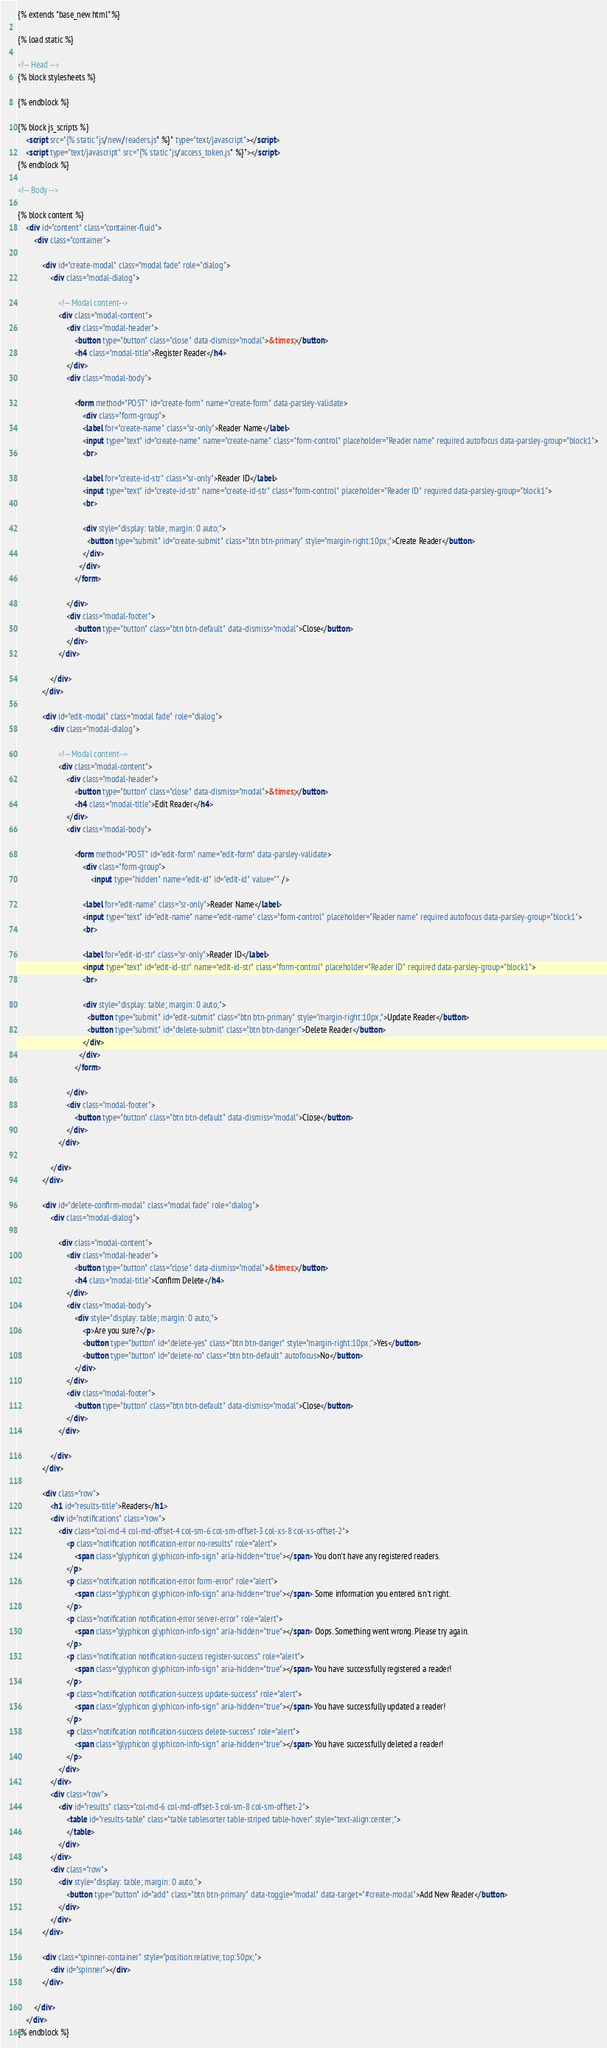Convert code to text. <code><loc_0><loc_0><loc_500><loc_500><_HTML_>{% extends "base_new.html" %}

{% load static %}

<!-- Head -->
{% block stylesheets %}
	
{% endblock %}

{% block js_scripts %}
	<script src="{% static "js/new/readers.js" %}" type="text/javascript"></script>
	<script type="text/javascript" src="{% static "js/access_token.js" %}"></script>
{% endblock %}

<!-- Body -->

{% block content %}
	<div id="content" class="container-fluid">
		<div class="container">

			<div id="create-modal" class="modal fade" role="dialog">
				<div class="modal-dialog">

					<!-- Modal content-->
					<div class="modal-content">
						<div class="modal-header">
							<button type="button" class="close" data-dismiss="modal">&times;</button>
							<h4 class="modal-title">Register Reader</h4>
						</div>
						<div class="modal-body">

							<form method="POST" id="create-form" name="create-form" data-parsley-validate>
								<div class="form-group">
							    <label for="create-name" class="sr-only">Reader Name</label>
							    <input type="text" id="create-name" name="create-name" class="form-control" placeholder="Reader name" required autofocus data-parsley-group="block1">
							    <br>

							    <label for="create-id-str" class="sr-only">Reader ID</label>
							    <input type="text" id="create-id-str" name="create-id-str" class="form-control" placeholder="Reader ID" required data-parsley-group="block1">
							    <br>

							    <div style="display: table; margin: 0 auto;">
							      <button type="submit" id="create-submit" class="btn btn-primary" style="margin-right:10px;">Create Reader</button>
							    </div>
							  </div>
							</form>

						</div>
						<div class="modal-footer">
							<button type="button" class="btn btn-default" data-dismiss="modal">Close</button>
						</div>
					</div>

				</div>
			</div>

			<div id="edit-modal" class="modal fade" role="dialog">
				<div class="modal-dialog">

					<!-- Modal content-->
					<div class="modal-content">
						<div class="modal-header">
							<button type="button" class="close" data-dismiss="modal">&times;</button>
							<h4 class="modal-title">Edit Reader</h4>
						</div>
						<div class="modal-body">

							<form method="POST" id="edit-form" name="edit-form" data-parsley-validate>
								<div class="form-group">
									<input type="hidden" name="edit-id" id="edit-id" value="" />

							    <label for="edit-name" class="sr-only">Reader Name</label>
							    <input type="text" id="edit-name" name="edit-name" class="form-control" placeholder="Reader name" required autofocus data-parsley-group="block1">
							    <br>

							    <label for="edit-id-str" class="sr-only">Reader ID</label>
							    <input type="text" id="edit-id-str" name="edit-id-str" class="form-control" placeholder="Reader ID" required data-parsley-group="block1">
							    <br>

							    <div style="display: table; margin: 0 auto;">
							      <button type="submit" id="edit-submit" class="btn btn-primary" style="margin-right:10px;">Update Reader</button>
							      <button type="submit" id="delete-submit" class="btn btn-danger">Delete Reader</button>
							    </div>
							  </div>
							</form>

						</div>
						<div class="modal-footer">
							<button type="button" class="btn btn-default" data-dismiss="modal">Close</button>
						</div>
					</div>

				</div>
			</div>

			<div id="delete-confirm-modal" class="modal fade" role="dialog">
				<div class="modal-dialog">

					<div class="modal-content">
						<div class="modal-header">
							<button type="button" class="close" data-dismiss="modal">&times;</button>
							<h4 class="modal-title">Confirm Delete</h4>
						</div>
						<div class="modal-body">
							<div style="display: table; margin: 0 auto;">
								<p>Are you sure?</p>
								<button type="button" id="delete-yes" class="btn btn-danger" style="margin-right:10px;">Yes</button>
								<button type="button" id="delete-no" class="btn btn-default" autofocus>No</button>
							</div>
						</div>
						<div class="modal-footer">
							<button type="button" class="btn btn-default" data-dismiss="modal">Close</button>
						</div>
					</div>

				</div>
			</div>

			<div class="row">
				<h1 id="results-title">Readers</h1>
				<div id="notifications" class="row">
					<div class="col-md-4 col-md-offset-4 col-sm-6 col-sm-offset-3 col-xs-8 col-xs-offset-2">
						<p class="notification notification-error no-results" role="alert">
							<span class="glyphicon glyphicon-info-sign" aria-hidden="true"></span> You don't have any registered readers.
						</p>
						<p class="notification notification-error form-error" role="alert">
							<span class="glyphicon glyphicon-info-sign" aria-hidden="true"></span> Some information you entered isn't right.
						</p>
						<p class="notification notification-error server-error" role="alert">
							<span class="glyphicon glyphicon-info-sign" aria-hidden="true"></span> Oops. Something went wrong. Please try again.
						</p>
						<p class="notification notification-success register-success" role="alert">
							<span class="glyphicon glyphicon-info-sign" aria-hidden="true"></span> You have successfully registered a reader!
						</p>
						<p class="notification notification-success update-success" role="alert">
							<span class="glyphicon glyphicon-info-sign" aria-hidden="true"></span> You have successfully updated a reader!
						</p>
						<p class="notification notification-success delete-success" role="alert">
							<span class="glyphicon glyphicon-info-sign" aria-hidden="true"></span> You have successfully deleted a reader!
						</p>
					</div>
				</div>
				<div class="row">
					<div id="results" class="col-md-6 col-md-offset-3 col-sm-8 col-sm-offset-2">
						<table id="results-table" class="table tablesorter table-striped table-hover" style="text-align:center;">
						</table>
					</div>
				</div>
				<div class="row">
					<div style="display: table; margin: 0 auto;">
						<button type="button" id="add" class="btn btn-primary" data-toggle="modal" data-target="#create-modal">Add New Reader</button>
					</div>
				</div>
			</div>

			<div class="spinner-container" style="position:relative; top:50px;">
				<div id="spinner"></div>
			</div>
			
		</div>
	</div>
{% endblock %}
</code> 